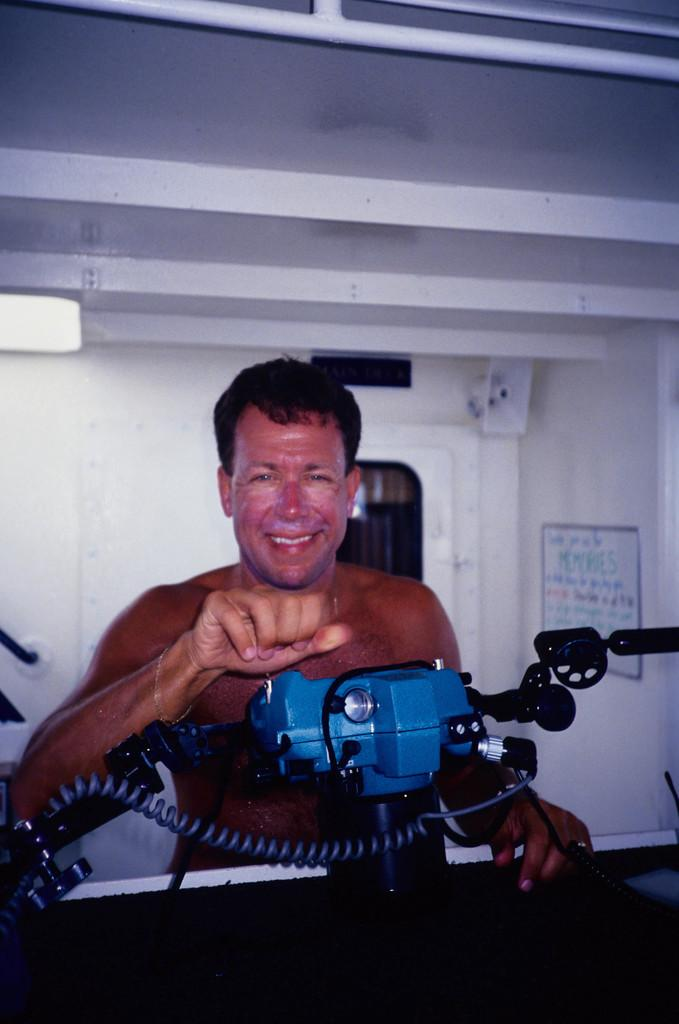Who or what is present in the image? There is a person in the image. What else can be seen in the image besides the person? There is a machine in the image. What is visible in the background of the image? There is a wall and a poster in the background of the image. What type of rod is being used by the person in the image? There is no rod visible in the image. Can you see a hydrant in the image? There is no hydrant present in the image. 